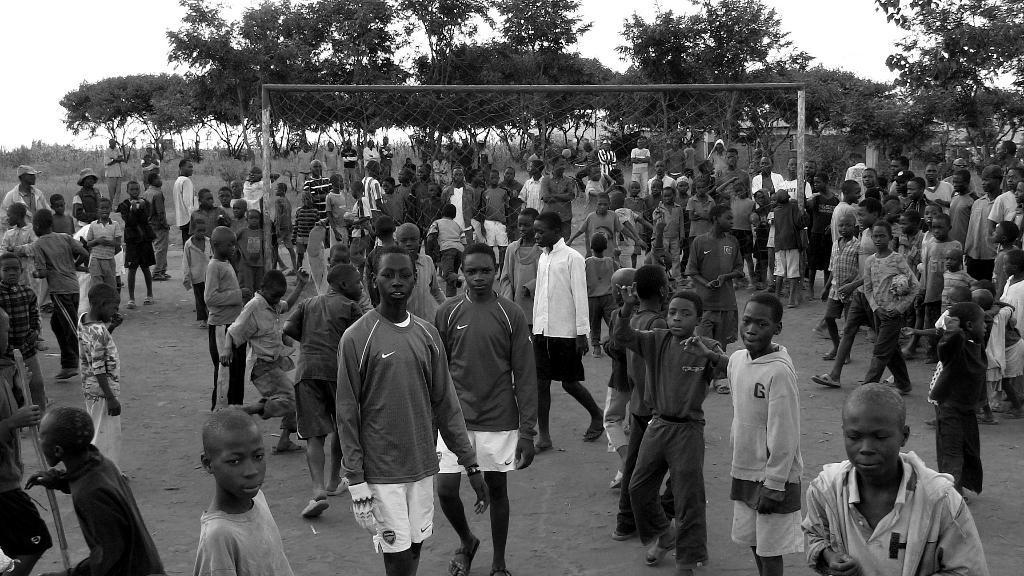How would you summarize this image in a sentence or two? It is a black and white image. In this image we can see many people. We can also see the players on the ground. In the background we can see the fencing net, trees, grass and also the sky. 